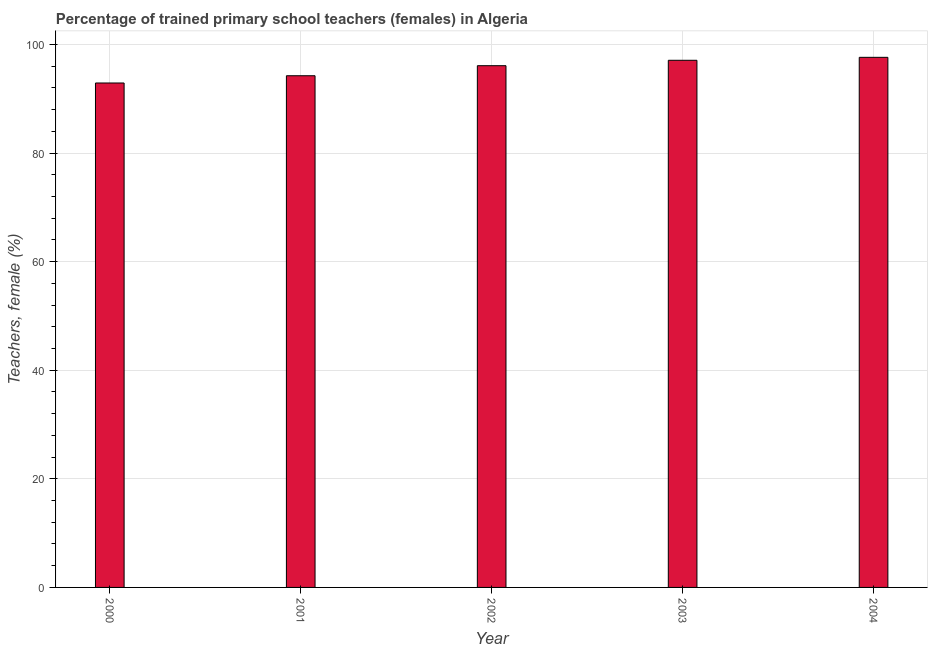What is the title of the graph?
Your answer should be very brief. Percentage of trained primary school teachers (females) in Algeria. What is the label or title of the Y-axis?
Offer a very short reply. Teachers, female (%). What is the percentage of trained female teachers in 2003?
Your response must be concise. 97.1. Across all years, what is the maximum percentage of trained female teachers?
Your response must be concise. 97.64. Across all years, what is the minimum percentage of trained female teachers?
Your answer should be very brief. 92.91. In which year was the percentage of trained female teachers maximum?
Your response must be concise. 2004. In which year was the percentage of trained female teachers minimum?
Provide a succinct answer. 2000. What is the sum of the percentage of trained female teachers?
Your response must be concise. 478. What is the difference between the percentage of trained female teachers in 2001 and 2002?
Your response must be concise. -1.85. What is the average percentage of trained female teachers per year?
Provide a succinct answer. 95.6. What is the median percentage of trained female teachers?
Your answer should be very brief. 96.1. Do a majority of the years between 2000 and 2004 (inclusive) have percentage of trained female teachers greater than 72 %?
Your response must be concise. Yes. What is the ratio of the percentage of trained female teachers in 2001 to that in 2003?
Provide a succinct answer. 0.97. Is the percentage of trained female teachers in 2000 less than that in 2004?
Make the answer very short. Yes. Is the difference between the percentage of trained female teachers in 2000 and 2004 greater than the difference between any two years?
Give a very brief answer. Yes. What is the difference between the highest and the second highest percentage of trained female teachers?
Keep it short and to the point. 0.54. What is the difference between the highest and the lowest percentage of trained female teachers?
Give a very brief answer. 4.73. In how many years, is the percentage of trained female teachers greater than the average percentage of trained female teachers taken over all years?
Offer a very short reply. 3. How many years are there in the graph?
Keep it short and to the point. 5. Are the values on the major ticks of Y-axis written in scientific E-notation?
Provide a short and direct response. No. What is the Teachers, female (%) in 2000?
Keep it short and to the point. 92.91. What is the Teachers, female (%) of 2001?
Your response must be concise. 94.25. What is the Teachers, female (%) of 2002?
Your answer should be very brief. 96.1. What is the Teachers, female (%) in 2003?
Give a very brief answer. 97.1. What is the Teachers, female (%) in 2004?
Provide a succinct answer. 97.64. What is the difference between the Teachers, female (%) in 2000 and 2001?
Provide a succinct answer. -1.34. What is the difference between the Teachers, female (%) in 2000 and 2002?
Your response must be concise. -3.18. What is the difference between the Teachers, female (%) in 2000 and 2003?
Give a very brief answer. -4.18. What is the difference between the Teachers, female (%) in 2000 and 2004?
Give a very brief answer. -4.73. What is the difference between the Teachers, female (%) in 2001 and 2002?
Give a very brief answer. -1.85. What is the difference between the Teachers, female (%) in 2001 and 2003?
Offer a very short reply. -2.85. What is the difference between the Teachers, female (%) in 2001 and 2004?
Your answer should be compact. -3.39. What is the difference between the Teachers, female (%) in 2002 and 2003?
Ensure brevity in your answer.  -1. What is the difference between the Teachers, female (%) in 2002 and 2004?
Keep it short and to the point. -1.54. What is the difference between the Teachers, female (%) in 2003 and 2004?
Offer a very short reply. -0.54. What is the ratio of the Teachers, female (%) in 2000 to that in 2001?
Make the answer very short. 0.99. What is the ratio of the Teachers, female (%) in 2000 to that in 2002?
Your answer should be compact. 0.97. What is the ratio of the Teachers, female (%) in 2000 to that in 2003?
Make the answer very short. 0.96. What is the ratio of the Teachers, female (%) in 2001 to that in 2002?
Your answer should be compact. 0.98. What is the ratio of the Teachers, female (%) in 2002 to that in 2004?
Ensure brevity in your answer.  0.98. 